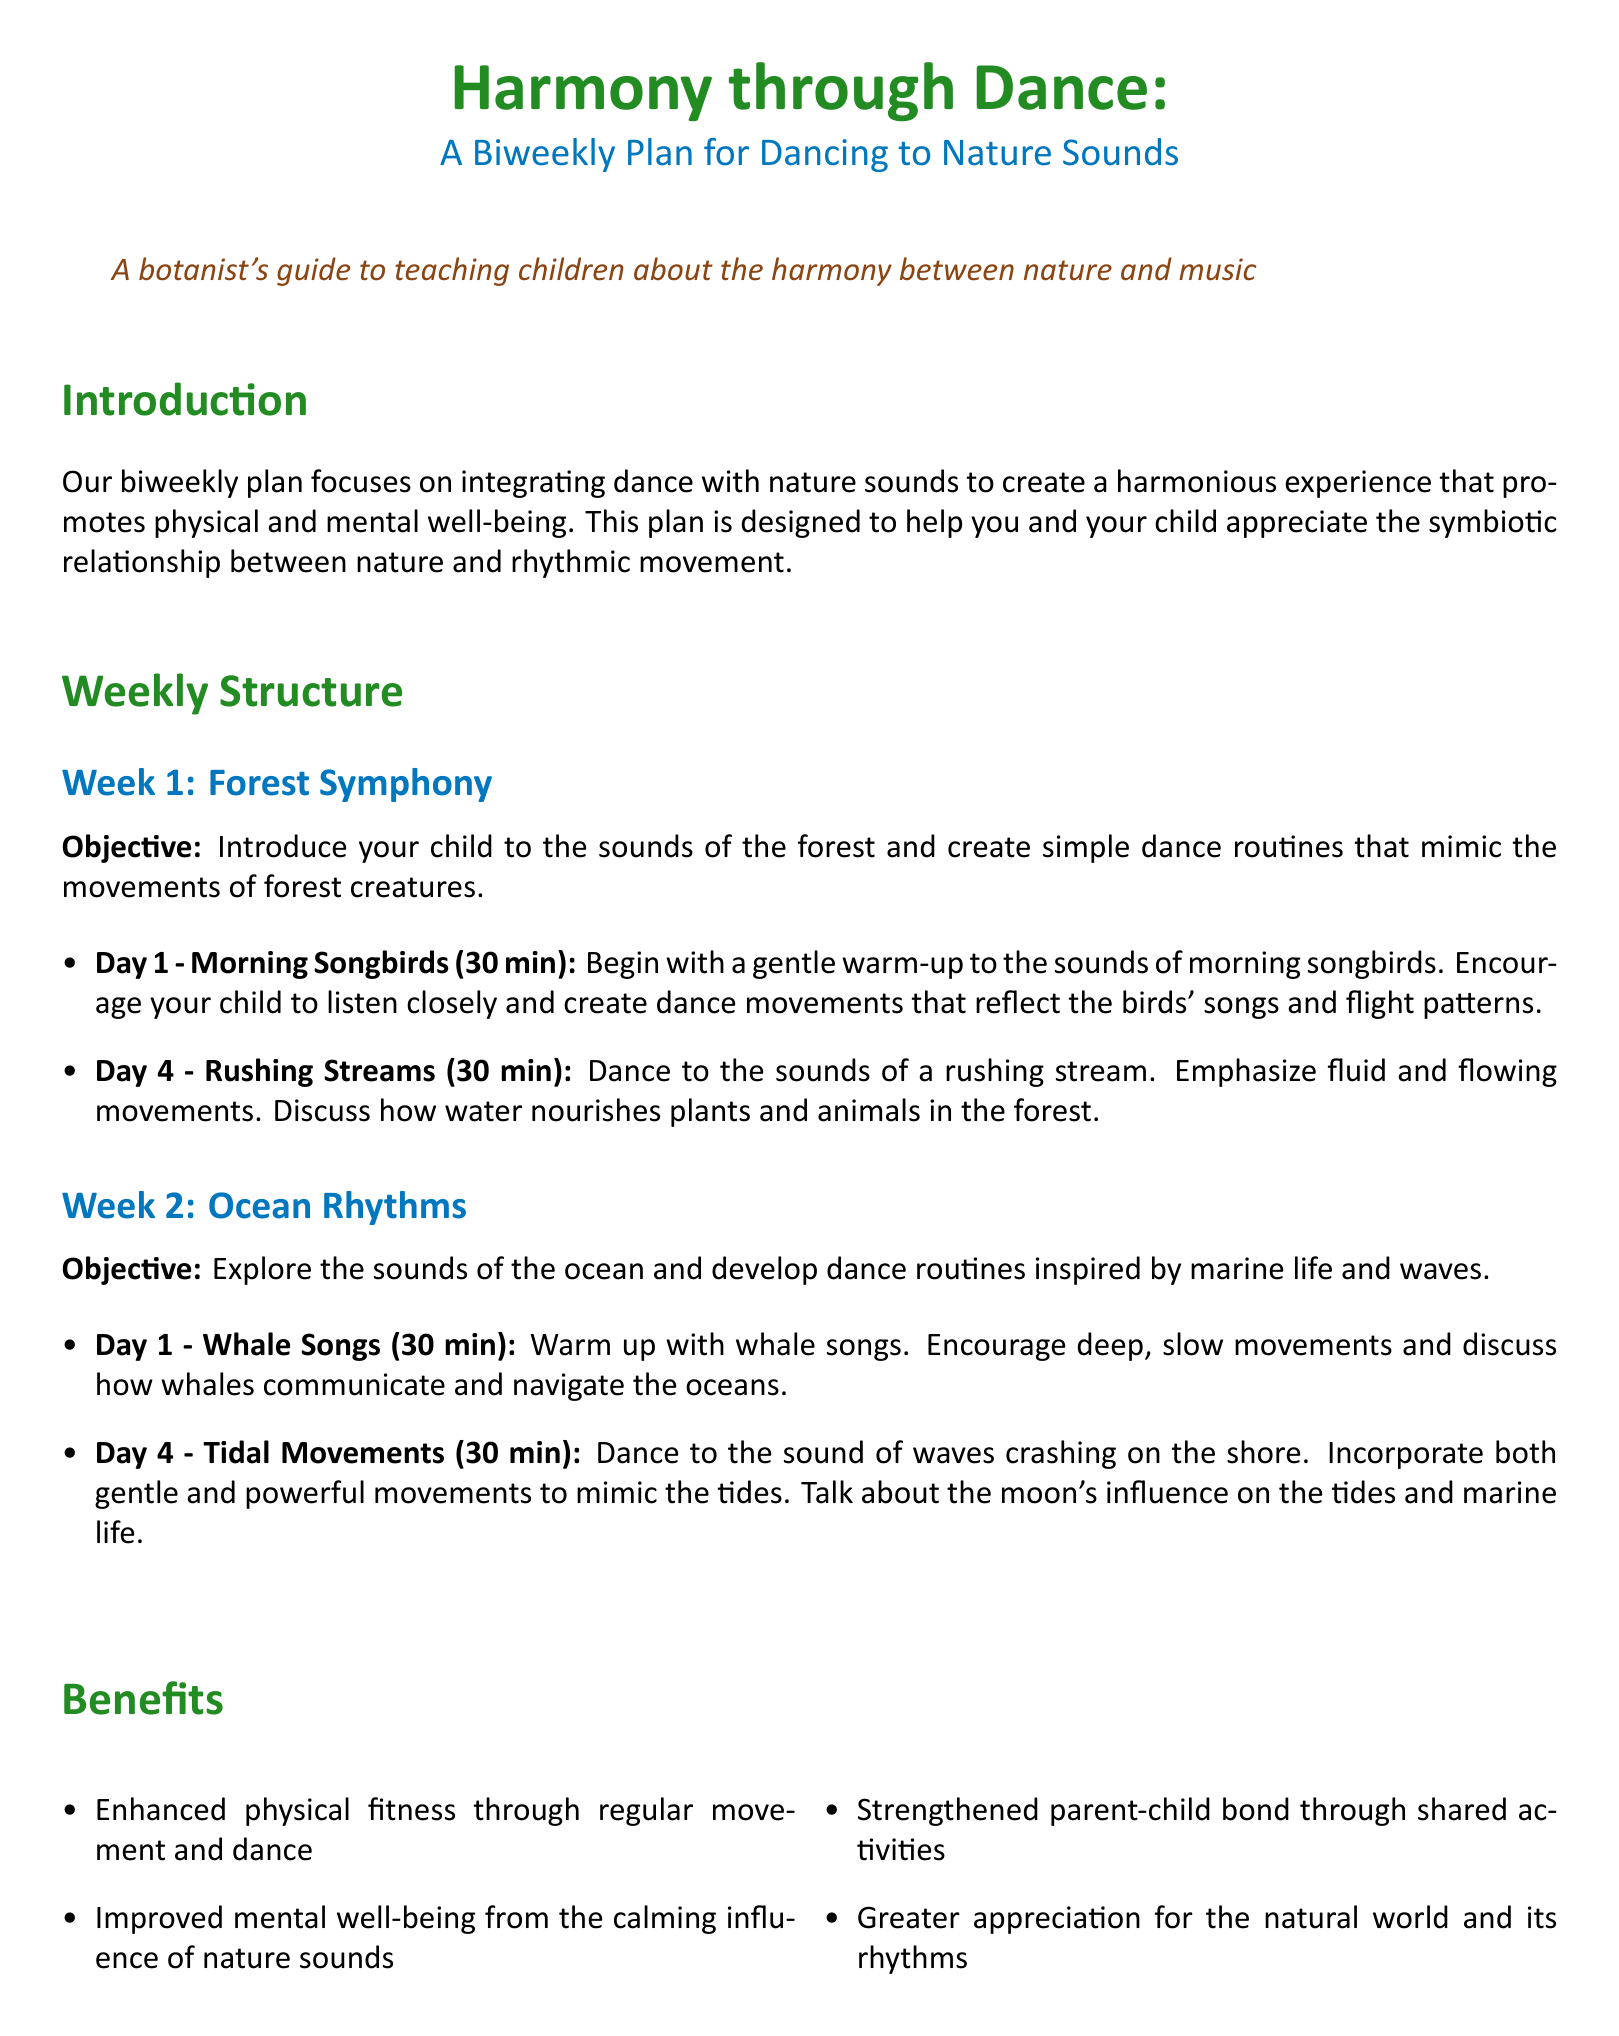What is the biweekly plan focused on? The biweekly plan focuses on integrating dance with nature sounds to create a harmonious experience that promotes physical and mental well-being.
Answer: Integrating dance with nature sounds What is the objective of Week 1? The objective of Week 1 is to introduce your child to the sounds of the forest and create simple dance routines that mimic the movements of forest creatures.
Answer: Introduce to forest sounds How long is each dance session? Each dance session is specified to be 30 minutes long.
Answer: 30 minutes What is the focus of Day 1 in Week 2? Day 1 in Week 2 focuses on warming up with whale songs and encourages deep, slow movements.
Answer: Whale songs Name one benefit of the workout plan. The document lists several benefits; one is enhanced physical fitness through regular movement and dance.
Answer: Enhanced physical fitness What should be discussed before and after each dance session? It is suggested to discuss the natural world and its sounds before and after each dance session to deepen understanding.
Answer: The natural world and its sounds What type of sounds does the plan incorporate on Day 4 of Week 2? The plan incorporates the sounds of waves crashing on the shore on Day 4 of Week 2.
Answer: Waves crashing What color is used for the titles in the document? The titles are colored forest green as per the styling defined in the document.
Answer: Forest green 